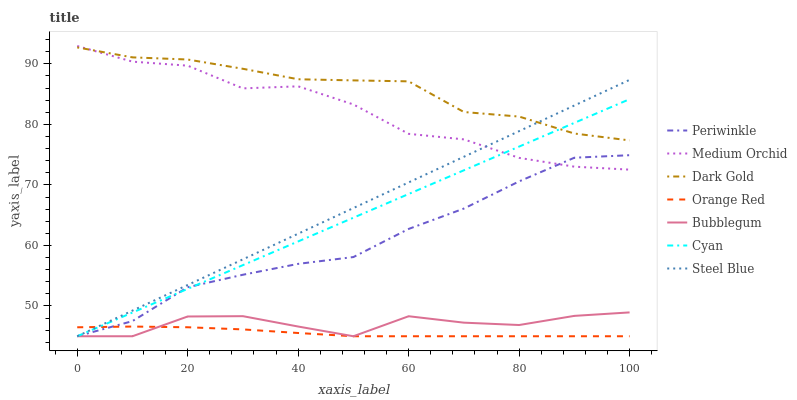Does Orange Red have the minimum area under the curve?
Answer yes or no. Yes. Does Dark Gold have the maximum area under the curve?
Answer yes or no. Yes. Does Medium Orchid have the minimum area under the curve?
Answer yes or no. No. Does Medium Orchid have the maximum area under the curve?
Answer yes or no. No. Is Cyan the smoothest?
Answer yes or no. Yes. Is Medium Orchid the roughest?
Answer yes or no. Yes. Is Steel Blue the smoothest?
Answer yes or no. No. Is Steel Blue the roughest?
Answer yes or no. No. Does Steel Blue have the lowest value?
Answer yes or no. Yes. Does Medium Orchid have the lowest value?
Answer yes or no. No. Does Medium Orchid have the highest value?
Answer yes or no. Yes. Does Steel Blue have the highest value?
Answer yes or no. No. Is Periwinkle less than Dark Gold?
Answer yes or no. Yes. Is Dark Gold greater than Periwinkle?
Answer yes or no. Yes. Does Bubblegum intersect Periwinkle?
Answer yes or no. Yes. Is Bubblegum less than Periwinkle?
Answer yes or no. No. Is Bubblegum greater than Periwinkle?
Answer yes or no. No. Does Periwinkle intersect Dark Gold?
Answer yes or no. No. 